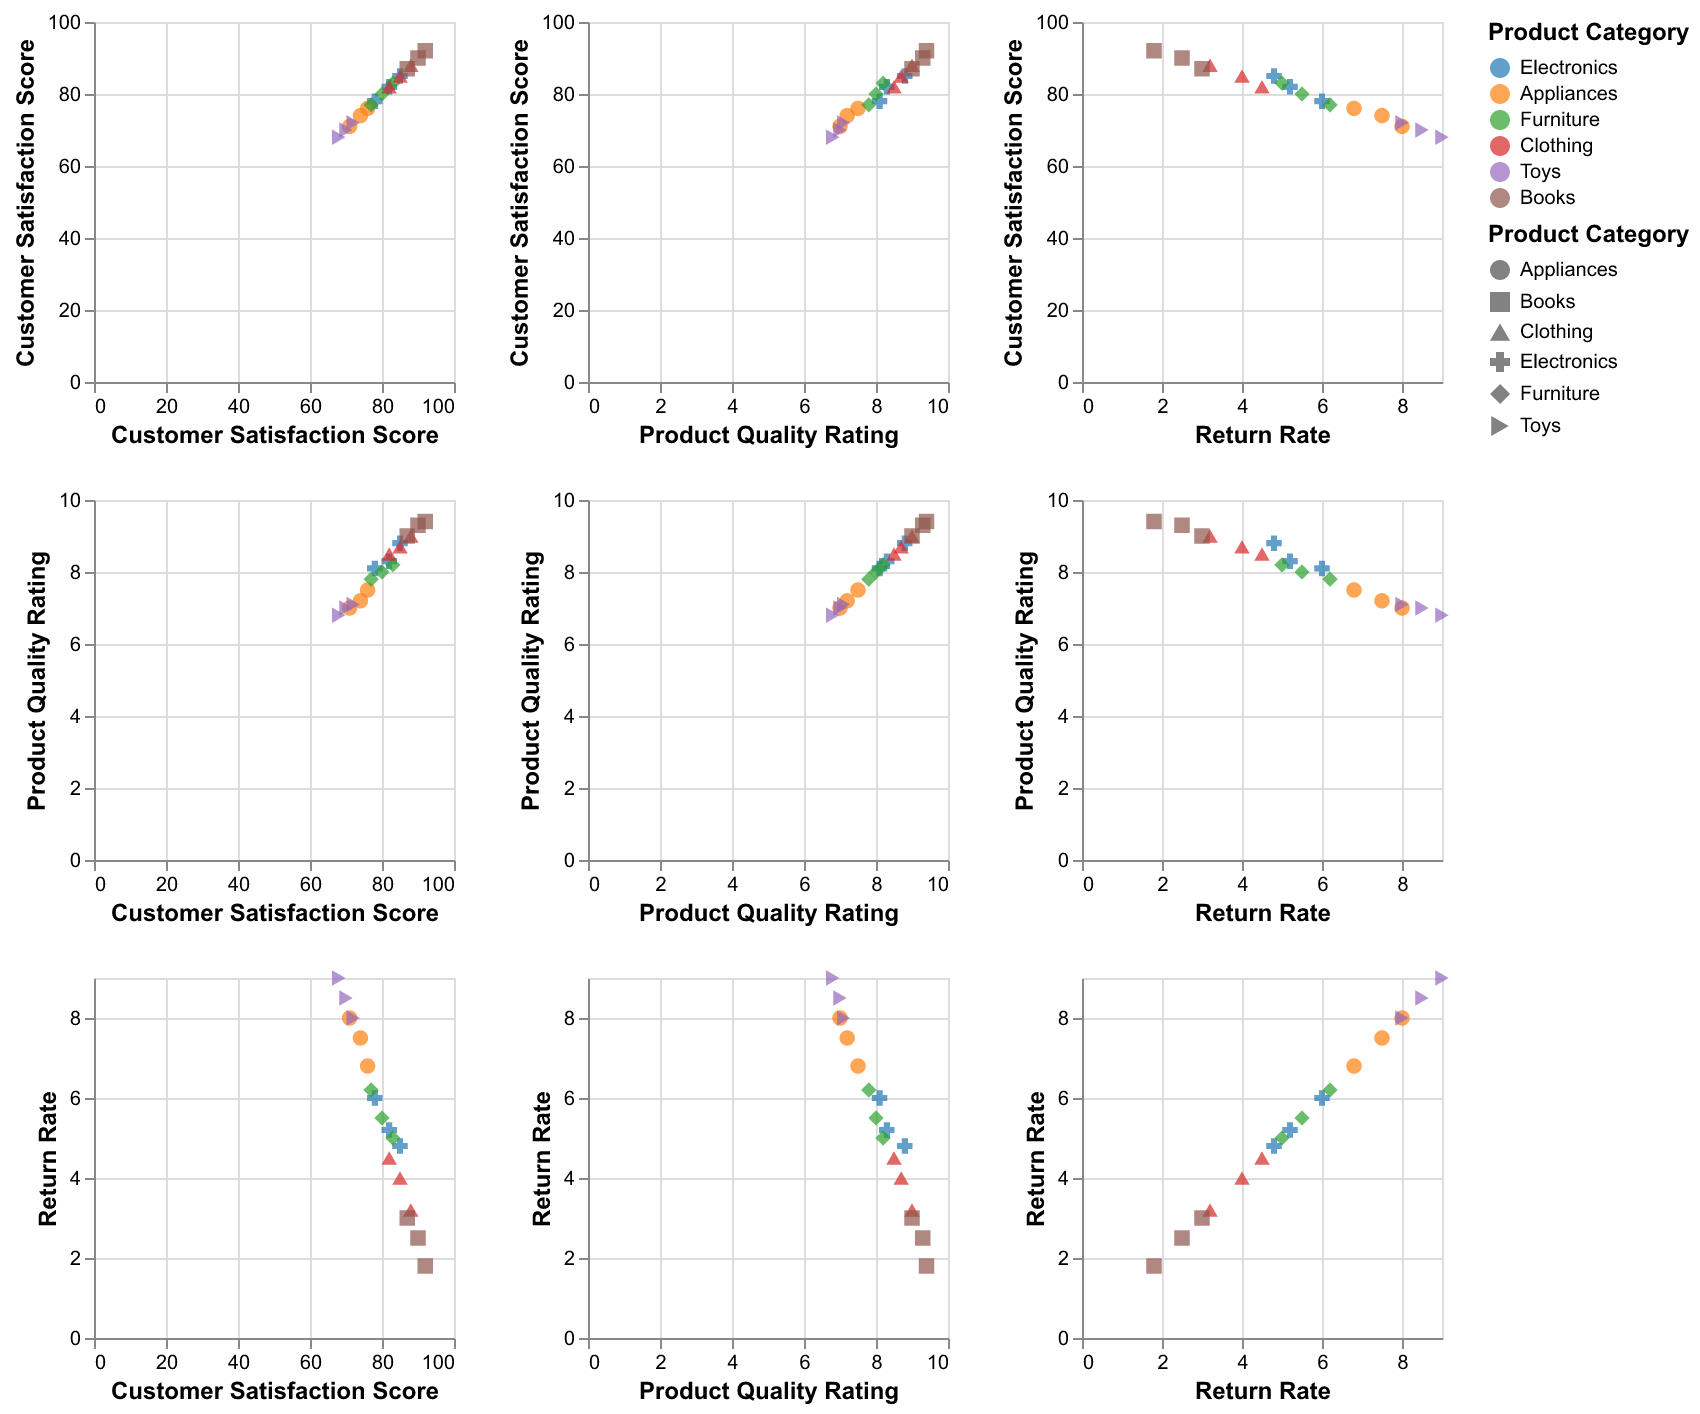What product category has the highest overall customer satisfaction scores? By looking at the scatter plot, determine which category has points located higher on the customer satisfaction score axis.
Answer: Books Are the return rates of Electronics generally higher or lower compared to Toys? Compare the return rate points for Electronics and Toys on the scatter plot matrix. The points for Electronics should be lower on the return rate axis than those for Toys.
Answer: Lower Which category shows a strong correlation between customer satisfaction and product quality? Observe the scatter plots of customer satisfaction vs. product quality. Identify which category's dots form a clear upward trend.
Answer: Books Is there a negative correlation between product quality ratings and return rates for any product category? Check the scatter plots of product quality ratings vs. return rates. Look for categories where higher product quality ratings correspond with lower return rates.
Answer: Yes, Clothing What category appears to have the most spread in customer satisfaction scores? Compare the spread of points along the customer satisfaction score axis for each category. Identify the category with the widest range.
Answer: Electronics Do higher product quality ratings generally lead to higher customer satisfaction scores? Look at the scatter plot matrix between product quality ratings and customer satisfaction scores across all categories. Note the overall trend of points in these plots.
Answer: Yes Which product category shows the least variation in return rates? Compare the scatter plots for return rates across different product categories. Look for the category with points that are closest together on the return rate axis.
Answer: Books What is the trend of the return rate with increasing customer satisfaction score for the Electronics category? Focus on the scatter plot of Electronics return rates vs. customer satisfaction scores. Determine if the points tend to move up or down as customer satisfaction scores increase.
Answer: Downward Is there a product category where increasing customer satisfaction scores do not significantly reduce return rates? Look at the scatter plots of each category's return rates vs. customer satisfaction scores. Identify any category where points don't show a clear downward trend.
Answer: Toys Among Appliances, Electronics, and Furniture, which category has the lowest average product quality rating? Review the scatter plots for Appliances, Electronics, and Furniture product quality ratings. Calculate the average value visually or by estimating.
Answer: Appliances 